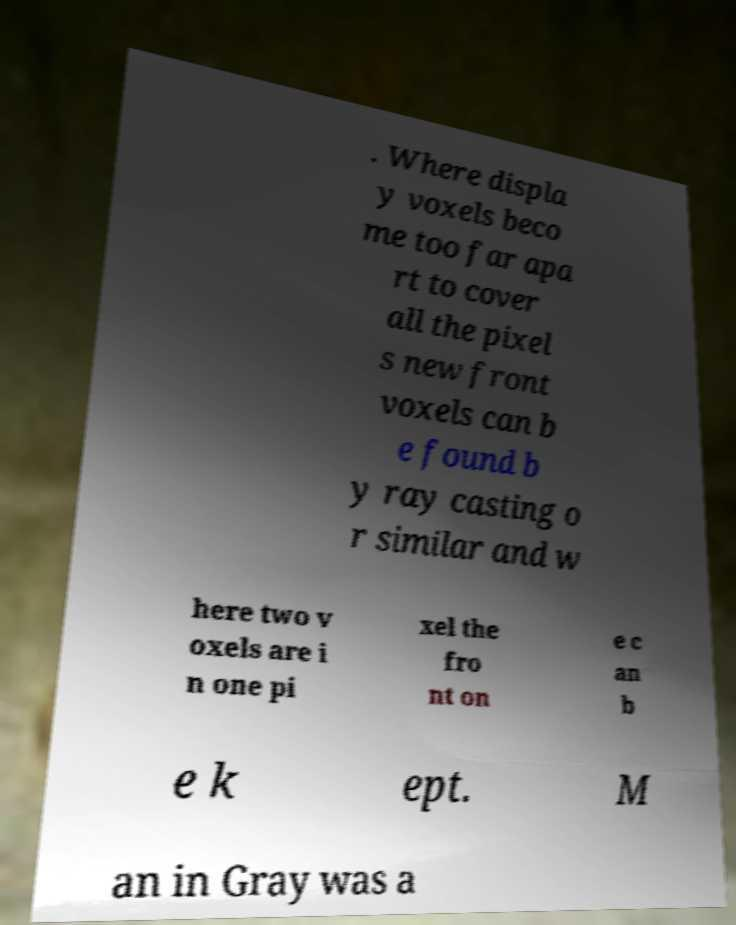Could you assist in decoding the text presented in this image and type it out clearly? . Where displa y voxels beco me too far apa rt to cover all the pixel s new front voxels can b e found b y ray casting o r similar and w here two v oxels are i n one pi xel the fro nt on e c an b e k ept. M an in Gray was a 